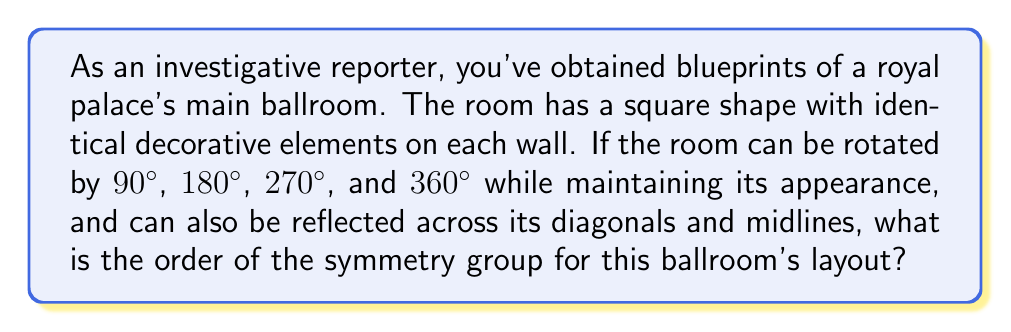Solve this math problem. To determine the order of the symmetry group, we need to count all the symmetry operations that leave the ballroom's layout unchanged. Let's break this down step-by-step:

1. Rotational symmetries:
   - 90° rotation (clockwise or counterclockwise)
   - 180° rotation
   - 270° rotation (equivalent to -90°)
   - 360° rotation (identity transformation)
   Total rotational symmetries: 4

2. Reflection symmetries:
   - Reflection across one diagonal
   - Reflection across the other diagonal
   - Reflection across the vertical midline
   - Reflection across the horizontal midline
   Total reflection symmetries: 4

3. The symmetry group of this square ballroom is known as the dihedral group $D_4$.

4. The order of a group is the number of elements in the group. In this case, it's the total number of symmetry operations.

5. Total number of symmetry operations = Rotational symmetries + Reflection symmetries
   $$ |D_4| = 4 + 4 = 8 $$

Therefore, the order of the symmetry group for this ballroom's layout is 8.
Answer: 8 